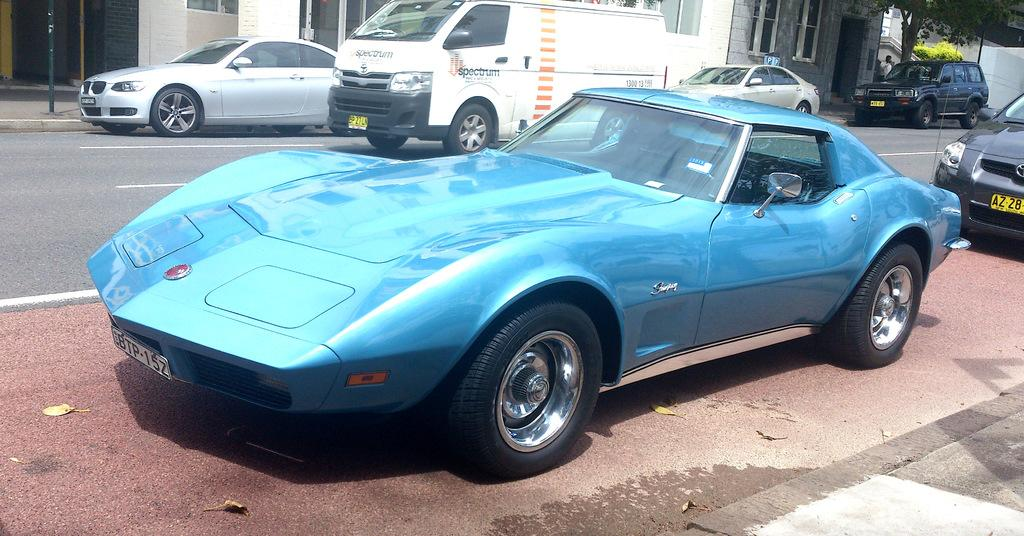What can be seen on the road in the image? There are vehicles on the road in the image. What is located on the right side of the image? There is a tree on the right side of the image. What is visible in the background of the image? There is a building in the background of the image. What is at the bottom of the image? There is a road visible at the bottom of the image. Are there any fairies flying around the tree in the image? There is no mention of fairies in the image, so we cannot confirm their presence. What news is being reported on the road in the image? There is no news being reported in the image; it features vehicles on the road. 